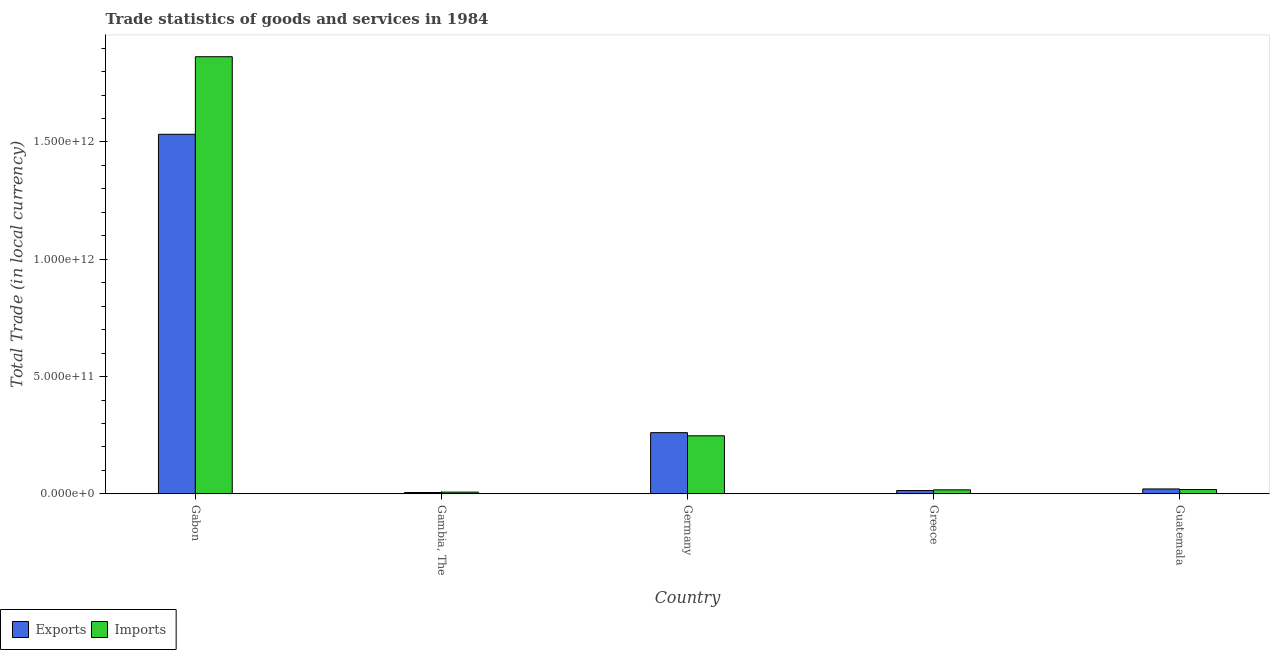How many different coloured bars are there?
Your answer should be compact. 2. How many groups of bars are there?
Keep it short and to the point. 5. Are the number of bars per tick equal to the number of legend labels?
Give a very brief answer. Yes. How many bars are there on the 3rd tick from the right?
Provide a succinct answer. 2. What is the label of the 1st group of bars from the left?
Make the answer very short. Gabon. In how many cases, is the number of bars for a given country not equal to the number of legend labels?
Provide a succinct answer. 0. What is the imports of goods and services in Gabon?
Provide a short and direct response. 1.86e+12. Across all countries, what is the maximum export of goods and services?
Give a very brief answer. 1.53e+12. Across all countries, what is the minimum export of goods and services?
Ensure brevity in your answer.  5.77e+09. In which country was the export of goods and services maximum?
Give a very brief answer. Gabon. In which country was the export of goods and services minimum?
Your answer should be very brief. Gambia, The. What is the total imports of goods and services in the graph?
Give a very brief answer. 2.15e+12. What is the difference between the export of goods and services in Gambia, The and that in Germany?
Your answer should be compact. -2.55e+11. What is the difference between the imports of goods and services in Germany and the export of goods and services in Guatemala?
Provide a succinct answer. 2.27e+11. What is the average imports of goods and services per country?
Provide a succinct answer. 4.31e+11. What is the difference between the export of goods and services and imports of goods and services in Gambia, The?
Keep it short and to the point. -1.61e+09. In how many countries, is the export of goods and services greater than 1100000000000 LCU?
Offer a terse response. 1. What is the ratio of the imports of goods and services in Germany to that in Greece?
Provide a short and direct response. 14.44. Is the imports of goods and services in Gabon less than that in Germany?
Offer a terse response. No. What is the difference between the highest and the second highest export of goods and services?
Your response must be concise. 1.27e+12. What is the difference between the highest and the lowest export of goods and services?
Your answer should be very brief. 1.53e+12. Is the sum of the imports of goods and services in Gabon and Guatemala greater than the maximum export of goods and services across all countries?
Ensure brevity in your answer.  Yes. What does the 1st bar from the left in Guatemala represents?
Give a very brief answer. Exports. What does the 2nd bar from the right in Guatemala represents?
Ensure brevity in your answer.  Exports. Are all the bars in the graph horizontal?
Give a very brief answer. No. How many countries are there in the graph?
Offer a very short reply. 5. What is the difference between two consecutive major ticks on the Y-axis?
Your answer should be compact. 5.00e+11. Are the values on the major ticks of Y-axis written in scientific E-notation?
Ensure brevity in your answer.  Yes. Where does the legend appear in the graph?
Your response must be concise. Bottom left. What is the title of the graph?
Offer a very short reply. Trade statistics of goods and services in 1984. Does "Travel Items" appear as one of the legend labels in the graph?
Keep it short and to the point. No. What is the label or title of the X-axis?
Offer a terse response. Country. What is the label or title of the Y-axis?
Offer a terse response. Total Trade (in local currency). What is the Total Trade (in local currency) of Exports in Gabon?
Provide a succinct answer. 1.53e+12. What is the Total Trade (in local currency) in Imports in Gabon?
Your answer should be very brief. 1.86e+12. What is the Total Trade (in local currency) in Exports in Gambia, The?
Your answer should be very brief. 5.77e+09. What is the Total Trade (in local currency) in Imports in Gambia, The?
Offer a terse response. 7.39e+09. What is the Total Trade (in local currency) of Exports in Germany?
Keep it short and to the point. 2.61e+11. What is the Total Trade (in local currency) of Imports in Germany?
Your response must be concise. 2.48e+11. What is the Total Trade (in local currency) of Exports in Greece?
Ensure brevity in your answer.  1.41e+1. What is the Total Trade (in local currency) in Imports in Greece?
Your response must be concise. 1.71e+1. What is the Total Trade (in local currency) in Exports in Guatemala?
Keep it short and to the point. 2.10e+1. What is the Total Trade (in local currency) in Imports in Guatemala?
Offer a very short reply. 1.85e+1. Across all countries, what is the maximum Total Trade (in local currency) of Exports?
Your response must be concise. 1.53e+12. Across all countries, what is the maximum Total Trade (in local currency) in Imports?
Your answer should be compact. 1.86e+12. Across all countries, what is the minimum Total Trade (in local currency) in Exports?
Provide a short and direct response. 5.77e+09. Across all countries, what is the minimum Total Trade (in local currency) of Imports?
Ensure brevity in your answer.  7.39e+09. What is the total Total Trade (in local currency) in Exports in the graph?
Provide a succinct answer. 1.83e+12. What is the total Total Trade (in local currency) in Imports in the graph?
Provide a short and direct response. 2.15e+12. What is the difference between the Total Trade (in local currency) in Exports in Gabon and that in Gambia, The?
Provide a short and direct response. 1.53e+12. What is the difference between the Total Trade (in local currency) in Imports in Gabon and that in Gambia, The?
Ensure brevity in your answer.  1.86e+12. What is the difference between the Total Trade (in local currency) in Exports in Gabon and that in Germany?
Provide a succinct answer. 1.27e+12. What is the difference between the Total Trade (in local currency) in Imports in Gabon and that in Germany?
Your answer should be very brief. 1.62e+12. What is the difference between the Total Trade (in local currency) of Exports in Gabon and that in Greece?
Your answer should be very brief. 1.52e+12. What is the difference between the Total Trade (in local currency) in Imports in Gabon and that in Greece?
Your answer should be compact. 1.85e+12. What is the difference between the Total Trade (in local currency) of Exports in Gabon and that in Guatemala?
Make the answer very short. 1.51e+12. What is the difference between the Total Trade (in local currency) of Imports in Gabon and that in Guatemala?
Offer a very short reply. 1.84e+12. What is the difference between the Total Trade (in local currency) in Exports in Gambia, The and that in Germany?
Ensure brevity in your answer.  -2.55e+11. What is the difference between the Total Trade (in local currency) in Imports in Gambia, The and that in Germany?
Your answer should be very brief. -2.40e+11. What is the difference between the Total Trade (in local currency) in Exports in Gambia, The and that in Greece?
Provide a succinct answer. -8.33e+09. What is the difference between the Total Trade (in local currency) in Imports in Gambia, The and that in Greece?
Your answer should be compact. -9.76e+09. What is the difference between the Total Trade (in local currency) in Exports in Gambia, The and that in Guatemala?
Provide a succinct answer. -1.52e+1. What is the difference between the Total Trade (in local currency) in Imports in Gambia, The and that in Guatemala?
Provide a short and direct response. -1.11e+1. What is the difference between the Total Trade (in local currency) of Exports in Germany and that in Greece?
Keep it short and to the point. 2.47e+11. What is the difference between the Total Trade (in local currency) of Imports in Germany and that in Greece?
Your response must be concise. 2.30e+11. What is the difference between the Total Trade (in local currency) of Exports in Germany and that in Guatemala?
Your response must be concise. 2.40e+11. What is the difference between the Total Trade (in local currency) in Imports in Germany and that in Guatemala?
Your answer should be very brief. 2.29e+11. What is the difference between the Total Trade (in local currency) in Exports in Greece and that in Guatemala?
Your answer should be compact. -6.86e+09. What is the difference between the Total Trade (in local currency) in Imports in Greece and that in Guatemala?
Offer a very short reply. -1.36e+09. What is the difference between the Total Trade (in local currency) in Exports in Gabon and the Total Trade (in local currency) in Imports in Gambia, The?
Ensure brevity in your answer.  1.53e+12. What is the difference between the Total Trade (in local currency) in Exports in Gabon and the Total Trade (in local currency) in Imports in Germany?
Offer a very short reply. 1.29e+12. What is the difference between the Total Trade (in local currency) in Exports in Gabon and the Total Trade (in local currency) in Imports in Greece?
Make the answer very short. 1.52e+12. What is the difference between the Total Trade (in local currency) of Exports in Gabon and the Total Trade (in local currency) of Imports in Guatemala?
Your response must be concise. 1.51e+12. What is the difference between the Total Trade (in local currency) in Exports in Gambia, The and the Total Trade (in local currency) in Imports in Germany?
Keep it short and to the point. -2.42e+11. What is the difference between the Total Trade (in local currency) in Exports in Gambia, The and the Total Trade (in local currency) in Imports in Greece?
Provide a short and direct response. -1.14e+1. What is the difference between the Total Trade (in local currency) of Exports in Gambia, The and the Total Trade (in local currency) of Imports in Guatemala?
Give a very brief answer. -1.27e+1. What is the difference between the Total Trade (in local currency) of Exports in Germany and the Total Trade (in local currency) of Imports in Greece?
Make the answer very short. 2.44e+11. What is the difference between the Total Trade (in local currency) in Exports in Germany and the Total Trade (in local currency) in Imports in Guatemala?
Offer a terse response. 2.42e+11. What is the difference between the Total Trade (in local currency) of Exports in Greece and the Total Trade (in local currency) of Imports in Guatemala?
Ensure brevity in your answer.  -4.40e+09. What is the average Total Trade (in local currency) of Exports per country?
Offer a very short reply. 3.67e+11. What is the average Total Trade (in local currency) in Imports per country?
Provide a short and direct response. 4.31e+11. What is the difference between the Total Trade (in local currency) in Exports and Total Trade (in local currency) in Imports in Gabon?
Your answer should be very brief. -3.31e+11. What is the difference between the Total Trade (in local currency) in Exports and Total Trade (in local currency) in Imports in Gambia, The?
Your response must be concise. -1.61e+09. What is the difference between the Total Trade (in local currency) of Exports and Total Trade (in local currency) of Imports in Germany?
Give a very brief answer. 1.34e+1. What is the difference between the Total Trade (in local currency) of Exports and Total Trade (in local currency) of Imports in Greece?
Your response must be concise. -3.04e+09. What is the difference between the Total Trade (in local currency) in Exports and Total Trade (in local currency) in Imports in Guatemala?
Make the answer very short. 2.46e+09. What is the ratio of the Total Trade (in local currency) of Exports in Gabon to that in Gambia, The?
Offer a terse response. 265.46. What is the ratio of the Total Trade (in local currency) of Imports in Gabon to that in Gambia, The?
Give a very brief answer. 252.22. What is the ratio of the Total Trade (in local currency) in Exports in Gabon to that in Germany?
Keep it short and to the point. 5.87. What is the ratio of the Total Trade (in local currency) of Imports in Gabon to that in Germany?
Offer a terse response. 7.53. What is the ratio of the Total Trade (in local currency) in Exports in Gabon to that in Greece?
Offer a very short reply. 108.68. What is the ratio of the Total Trade (in local currency) in Imports in Gabon to that in Greece?
Give a very brief answer. 108.68. What is the ratio of the Total Trade (in local currency) of Exports in Gabon to that in Guatemala?
Your answer should be compact. 73.12. What is the ratio of the Total Trade (in local currency) in Imports in Gabon to that in Guatemala?
Provide a short and direct response. 100.69. What is the ratio of the Total Trade (in local currency) in Exports in Gambia, The to that in Germany?
Your answer should be very brief. 0.02. What is the ratio of the Total Trade (in local currency) of Imports in Gambia, The to that in Germany?
Make the answer very short. 0.03. What is the ratio of the Total Trade (in local currency) of Exports in Gambia, The to that in Greece?
Offer a terse response. 0.41. What is the ratio of the Total Trade (in local currency) of Imports in Gambia, The to that in Greece?
Provide a succinct answer. 0.43. What is the ratio of the Total Trade (in local currency) of Exports in Gambia, The to that in Guatemala?
Provide a succinct answer. 0.28. What is the ratio of the Total Trade (in local currency) of Imports in Gambia, The to that in Guatemala?
Offer a terse response. 0.4. What is the ratio of the Total Trade (in local currency) of Exports in Germany to that in Greece?
Provide a succinct answer. 18.5. What is the ratio of the Total Trade (in local currency) of Imports in Germany to that in Greece?
Your response must be concise. 14.44. What is the ratio of the Total Trade (in local currency) in Exports in Germany to that in Guatemala?
Your response must be concise. 12.45. What is the ratio of the Total Trade (in local currency) in Imports in Germany to that in Guatemala?
Provide a short and direct response. 13.38. What is the ratio of the Total Trade (in local currency) in Exports in Greece to that in Guatemala?
Provide a succinct answer. 0.67. What is the ratio of the Total Trade (in local currency) in Imports in Greece to that in Guatemala?
Keep it short and to the point. 0.93. What is the difference between the highest and the second highest Total Trade (in local currency) of Exports?
Your response must be concise. 1.27e+12. What is the difference between the highest and the second highest Total Trade (in local currency) of Imports?
Provide a succinct answer. 1.62e+12. What is the difference between the highest and the lowest Total Trade (in local currency) of Exports?
Ensure brevity in your answer.  1.53e+12. What is the difference between the highest and the lowest Total Trade (in local currency) in Imports?
Ensure brevity in your answer.  1.86e+12. 